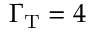<formula> <loc_0><loc_0><loc_500><loc_500>\Gamma _ { T } = 4</formula> 